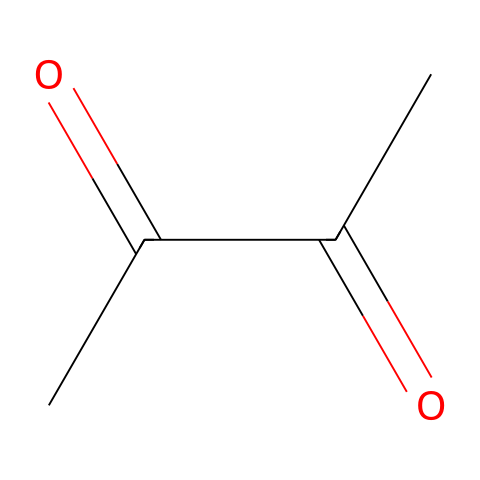how many carbon atoms are in diacetyl? The SMILES representation indicates two carbonyl (C=O) groups and two methyl (C) groups, which sums up to four carbon atoms in total.
Answer: four what is the functional group of diacetyl? The presence of the carbonyl groups (C=O) in the structure indicates that diacetyl is classified as a ketone, as ketones contain at least one carbonyl group adjacent to two carbon atoms.
Answer: ketone what is the total number of oxygen atoms in diacetyl? By analyzing the SMILES structure, there are two carbonyl groups, each containing one oxygen atom, leading to a total of two oxygen atoms in diacetyl.
Answer: two which part of the structure gives diacetyl its buttery notes? The two carbonyl (C=O) groups in the structure are responsible for the characteristic buttery aroma of diacetyl, common in some wines.
Answer: carbonyl groups what is the molecular formula of diacetyl? From the structure represented by the SMILES, we sum the number of carbon (C), hydrogen (H), and oxygen (O) atoms, arriving at the molecular formula C4H6O2 for diacetyl.
Answer: C4H6O2 why is diacetyl classified as a ketone rather than an aldehyde? Diacetyl has carbonyl groups located between carbon atoms (in this case, surrounded by other carbon atoms), unlike aldehydes, where the carbonyl group is at the terminal position of the carbon chain.
Answer: ketone how does the structure of diacetyl influence its volatility? The presence of carbonyl groups in the diacetyl structure enhances its volatility compared to less polar compounds, making it easier for the molecules to evaporate and contribute to aroma.
Answer: volatility 